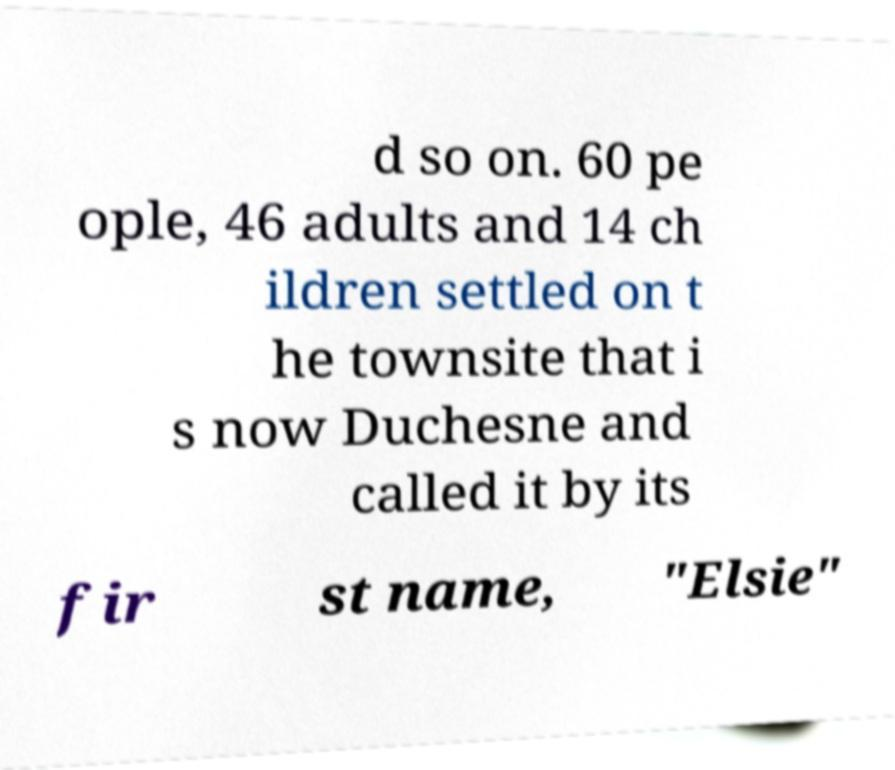There's text embedded in this image that I need extracted. Can you transcribe it verbatim? d so on. 60 pe ople, 46 adults and 14 ch ildren settled on t he townsite that i s now Duchesne and called it by its fir st name, "Elsie" 